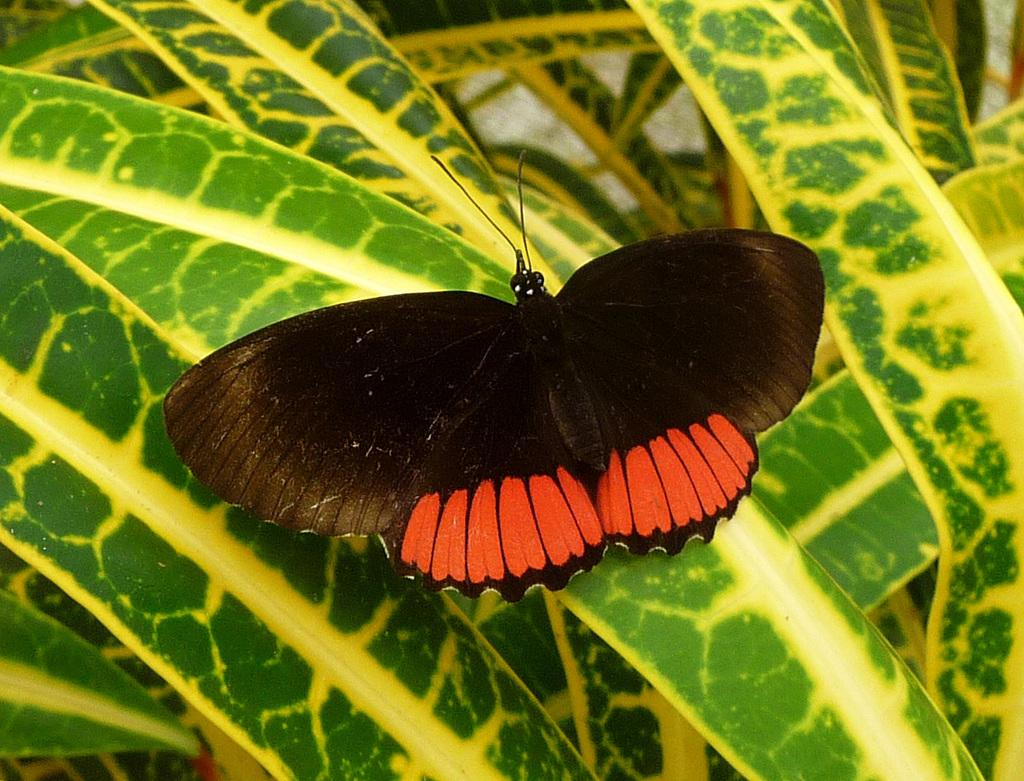What is the main subject in the image? There is a butterfly in the image. Where is the butterfly located? The butterfly is on a leaf. What type of guitar can be seen in the image? There is no guitar present in the image; it features a butterfly on a leaf. Can you tell me if the butterfly is crying or smiling in the image? Butterflies do not have the ability to cry or smile, so this question cannot be answered definitively from the image. 